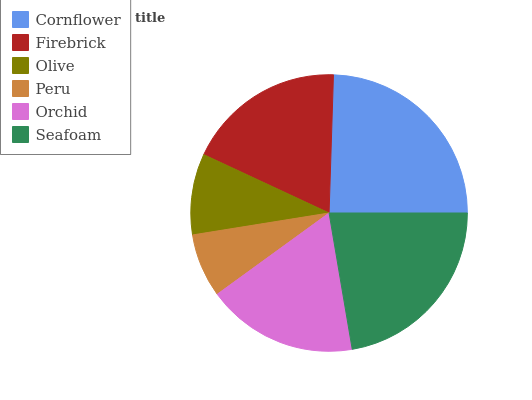Is Peru the minimum?
Answer yes or no. Yes. Is Cornflower the maximum?
Answer yes or no. Yes. Is Firebrick the minimum?
Answer yes or no. No. Is Firebrick the maximum?
Answer yes or no. No. Is Cornflower greater than Firebrick?
Answer yes or no. Yes. Is Firebrick less than Cornflower?
Answer yes or no. Yes. Is Firebrick greater than Cornflower?
Answer yes or no. No. Is Cornflower less than Firebrick?
Answer yes or no. No. Is Firebrick the high median?
Answer yes or no. Yes. Is Orchid the low median?
Answer yes or no. Yes. Is Seafoam the high median?
Answer yes or no. No. Is Cornflower the low median?
Answer yes or no. No. 